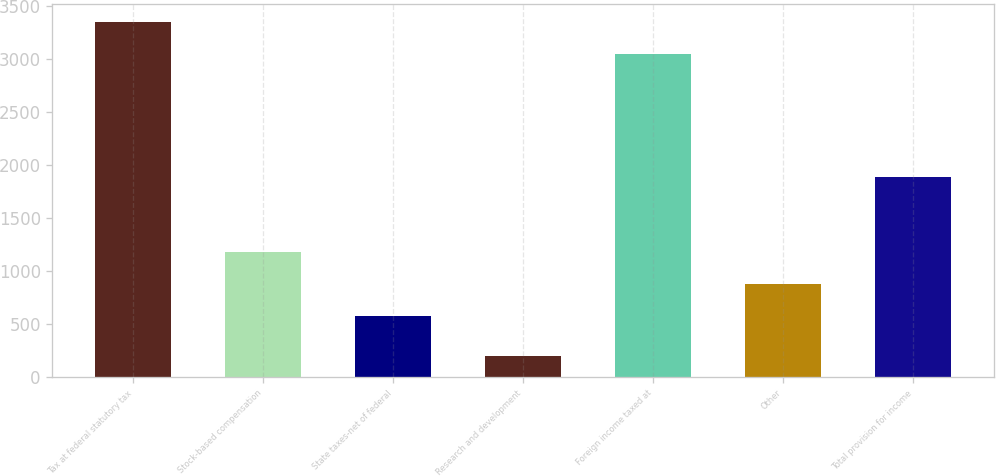Convert chart to OTSL. <chart><loc_0><loc_0><loc_500><loc_500><bar_chart><fcel>Tax at federal statutory tax<fcel>Stock-based compensation<fcel>State taxes-net of federal<fcel>Research and development<fcel>Foreign income taxed at<fcel>Other<fcel>Total provision for income<nl><fcel>3350.8<fcel>1180.6<fcel>573<fcel>199<fcel>3047<fcel>876.8<fcel>1888<nl></chart> 